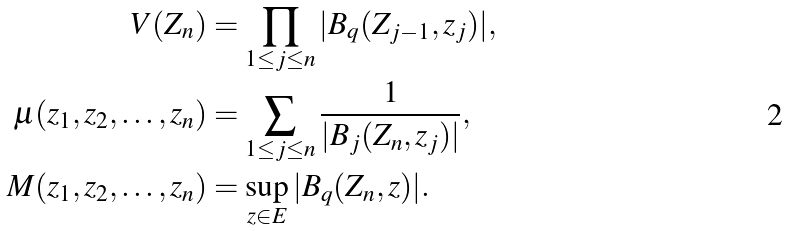<formula> <loc_0><loc_0><loc_500><loc_500>V ( Z _ { n } ) & = \prod _ { 1 \leq j \leq n } | B _ { q } ( Z _ { j - 1 } , z _ { j } ) | , \\ \mu ( z _ { 1 } , z _ { 2 } , \dots , z _ { n } ) & = \sum _ { 1 \leq j \leq n } \frac { 1 } { | B _ { j } ( Z _ { n } , z _ { j } ) | } , \\ M ( z _ { 1 } , z _ { 2 } , \dots , z _ { n } ) & = \sup _ { z \in E } | B _ { q } ( Z _ { n } , z ) | .</formula> 